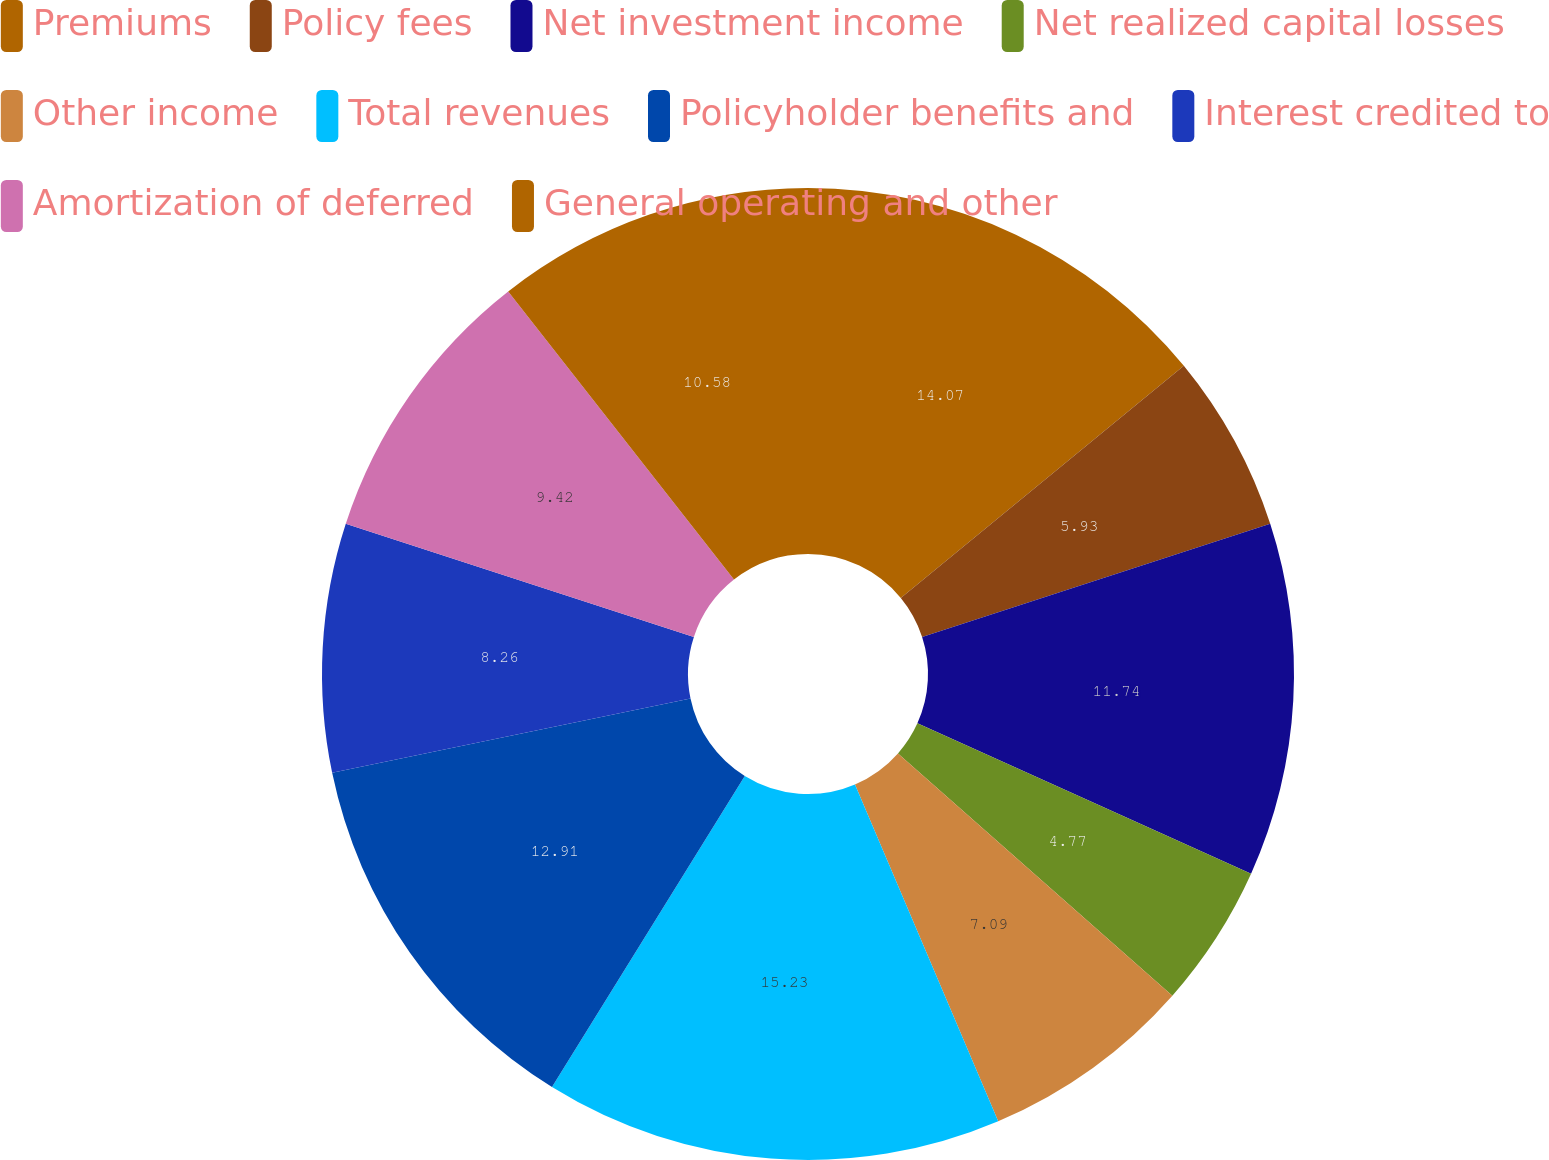Convert chart. <chart><loc_0><loc_0><loc_500><loc_500><pie_chart><fcel>Premiums<fcel>Policy fees<fcel>Net investment income<fcel>Net realized capital losses<fcel>Other income<fcel>Total revenues<fcel>Policyholder benefits and<fcel>Interest credited to<fcel>Amortization of deferred<fcel>General operating and other<nl><fcel>14.07%<fcel>5.93%<fcel>11.74%<fcel>4.77%<fcel>7.09%<fcel>15.23%<fcel>12.91%<fcel>8.26%<fcel>9.42%<fcel>10.58%<nl></chart> 